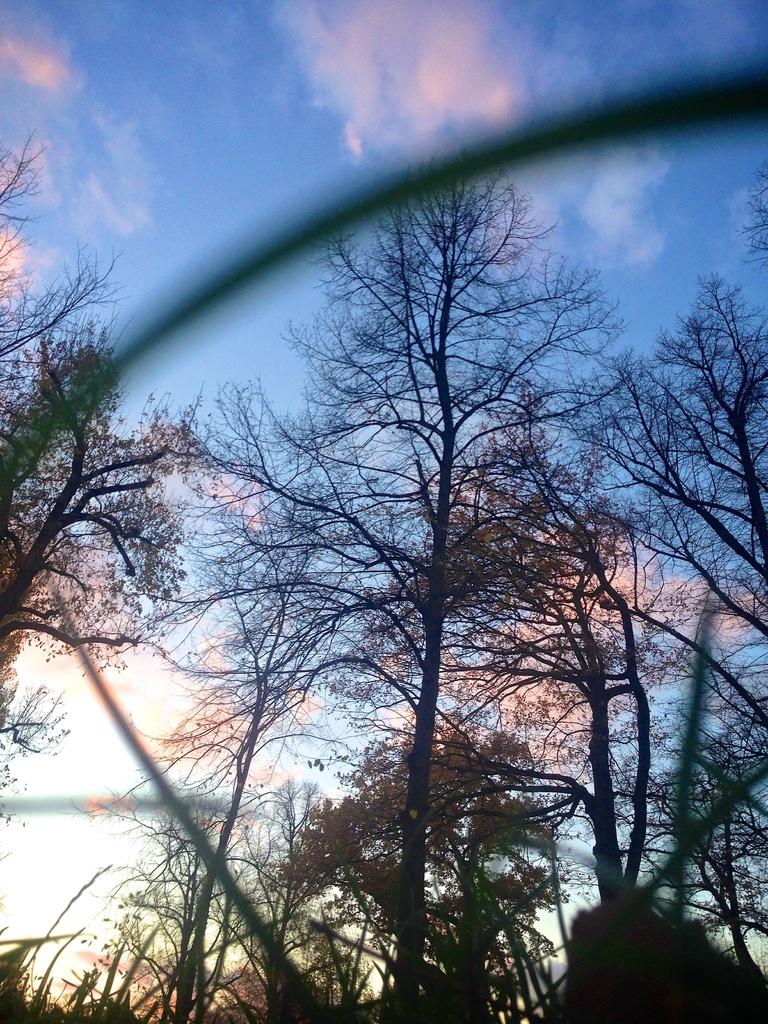What type of vegetation can be seen in the image? There are trees in the image. What else can be seen in the image besides the trees? There are other objects in the image. What is visible in the background of the image? The sky is visible in the background of the image. How much money is being exchanged between the trees in the image? There is no money being exchanged in the image, as it features trees and other objects. What type of roof can be seen on top of the trees in the image? There is no roof present in the image, as it features trees and other objects. 